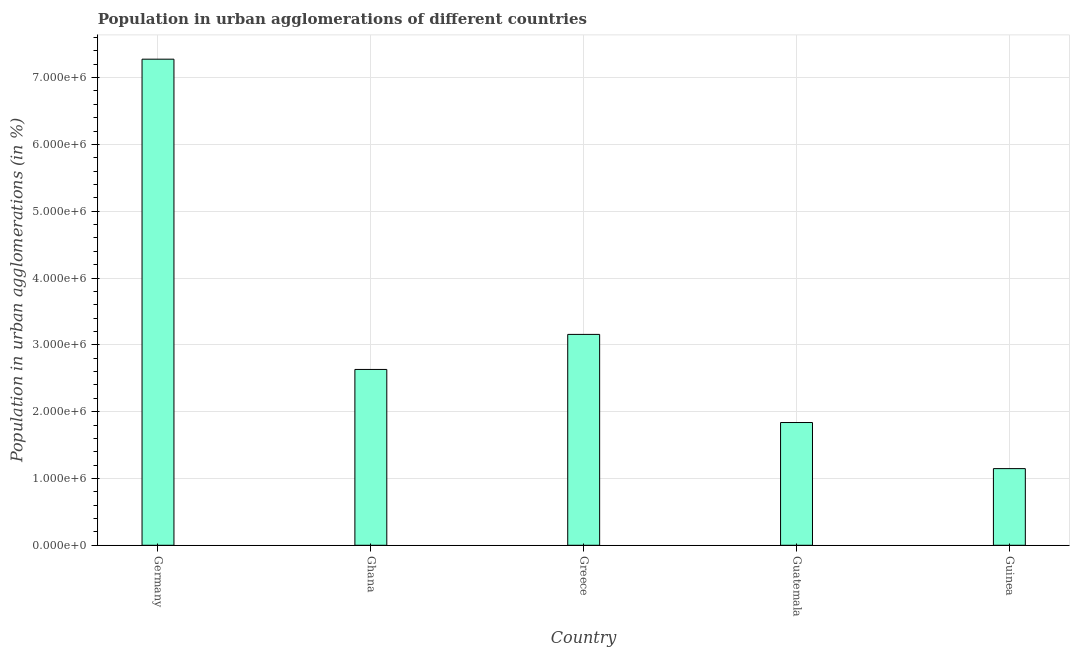Does the graph contain any zero values?
Offer a terse response. No. Does the graph contain grids?
Your answer should be very brief. Yes. What is the title of the graph?
Give a very brief answer. Population in urban agglomerations of different countries. What is the label or title of the Y-axis?
Your answer should be very brief. Population in urban agglomerations (in %). What is the population in urban agglomerations in Guatemala?
Ensure brevity in your answer.  1.84e+06. Across all countries, what is the maximum population in urban agglomerations?
Ensure brevity in your answer.  7.28e+06. Across all countries, what is the minimum population in urban agglomerations?
Offer a very short reply. 1.15e+06. In which country was the population in urban agglomerations maximum?
Your answer should be very brief. Germany. In which country was the population in urban agglomerations minimum?
Provide a short and direct response. Guinea. What is the sum of the population in urban agglomerations?
Your response must be concise. 1.60e+07. What is the difference between the population in urban agglomerations in Ghana and Guinea?
Provide a succinct answer. 1.48e+06. What is the average population in urban agglomerations per country?
Provide a short and direct response. 3.21e+06. What is the median population in urban agglomerations?
Make the answer very short. 2.63e+06. In how many countries, is the population in urban agglomerations greater than 1600000 %?
Offer a terse response. 4. What is the ratio of the population in urban agglomerations in Guatemala to that in Guinea?
Provide a succinct answer. 1.6. Is the difference between the population in urban agglomerations in Ghana and Greece greater than the difference between any two countries?
Your answer should be compact. No. What is the difference between the highest and the second highest population in urban agglomerations?
Offer a very short reply. 4.12e+06. What is the difference between the highest and the lowest population in urban agglomerations?
Your answer should be compact. 6.13e+06. What is the difference between two consecutive major ticks on the Y-axis?
Make the answer very short. 1.00e+06. Are the values on the major ticks of Y-axis written in scientific E-notation?
Make the answer very short. Yes. What is the Population in urban agglomerations (in %) in Germany?
Offer a terse response. 7.28e+06. What is the Population in urban agglomerations (in %) of Ghana?
Keep it short and to the point. 2.63e+06. What is the Population in urban agglomerations (in %) of Greece?
Offer a terse response. 3.16e+06. What is the Population in urban agglomerations (in %) of Guatemala?
Your answer should be very brief. 1.84e+06. What is the Population in urban agglomerations (in %) in Guinea?
Your response must be concise. 1.15e+06. What is the difference between the Population in urban agglomerations (in %) in Germany and Ghana?
Your answer should be compact. 4.64e+06. What is the difference between the Population in urban agglomerations (in %) in Germany and Greece?
Make the answer very short. 4.12e+06. What is the difference between the Population in urban agglomerations (in %) in Germany and Guatemala?
Provide a short and direct response. 5.44e+06. What is the difference between the Population in urban agglomerations (in %) in Germany and Guinea?
Offer a very short reply. 6.13e+06. What is the difference between the Population in urban agglomerations (in %) in Ghana and Greece?
Your answer should be compact. -5.24e+05. What is the difference between the Population in urban agglomerations (in %) in Ghana and Guatemala?
Ensure brevity in your answer.  7.95e+05. What is the difference between the Population in urban agglomerations (in %) in Ghana and Guinea?
Your response must be concise. 1.48e+06. What is the difference between the Population in urban agglomerations (in %) in Greece and Guatemala?
Provide a short and direct response. 1.32e+06. What is the difference between the Population in urban agglomerations (in %) in Greece and Guinea?
Your answer should be very brief. 2.01e+06. What is the difference between the Population in urban agglomerations (in %) in Guatemala and Guinea?
Offer a terse response. 6.90e+05. What is the ratio of the Population in urban agglomerations (in %) in Germany to that in Ghana?
Your answer should be very brief. 2.77. What is the ratio of the Population in urban agglomerations (in %) in Germany to that in Greece?
Provide a short and direct response. 2.31. What is the ratio of the Population in urban agglomerations (in %) in Germany to that in Guatemala?
Your answer should be compact. 3.96. What is the ratio of the Population in urban agglomerations (in %) in Germany to that in Guinea?
Offer a very short reply. 6.34. What is the ratio of the Population in urban agglomerations (in %) in Ghana to that in Greece?
Offer a terse response. 0.83. What is the ratio of the Population in urban agglomerations (in %) in Ghana to that in Guatemala?
Your answer should be compact. 1.43. What is the ratio of the Population in urban agglomerations (in %) in Ghana to that in Guinea?
Provide a short and direct response. 2.29. What is the ratio of the Population in urban agglomerations (in %) in Greece to that in Guatemala?
Your response must be concise. 1.72. What is the ratio of the Population in urban agglomerations (in %) in Greece to that in Guinea?
Provide a short and direct response. 2.75. What is the ratio of the Population in urban agglomerations (in %) in Guatemala to that in Guinea?
Your answer should be compact. 1.6. 